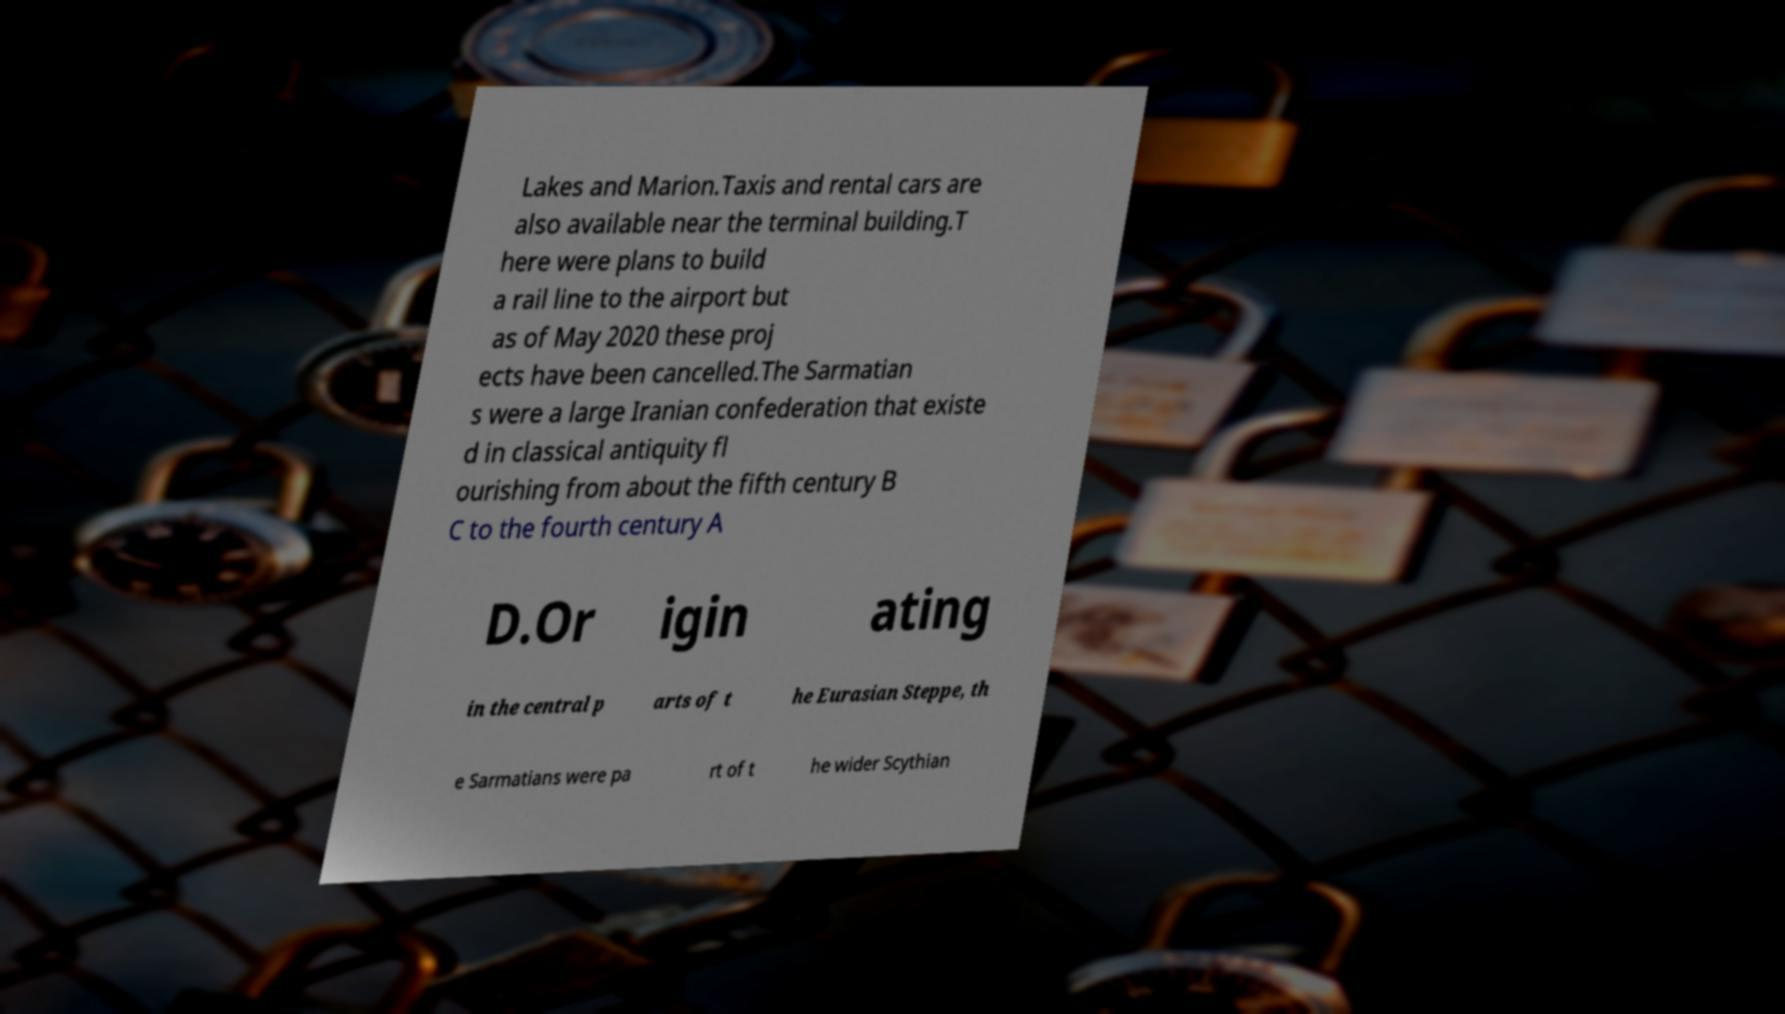Could you assist in decoding the text presented in this image and type it out clearly? Lakes and Marion.Taxis and rental cars are also available near the terminal building.T here were plans to build a rail line to the airport but as of May 2020 these proj ects have been cancelled.The Sarmatian s were a large Iranian confederation that existe d in classical antiquity fl ourishing from about the fifth century B C to the fourth century A D.Or igin ating in the central p arts of t he Eurasian Steppe, th e Sarmatians were pa rt of t he wider Scythian 